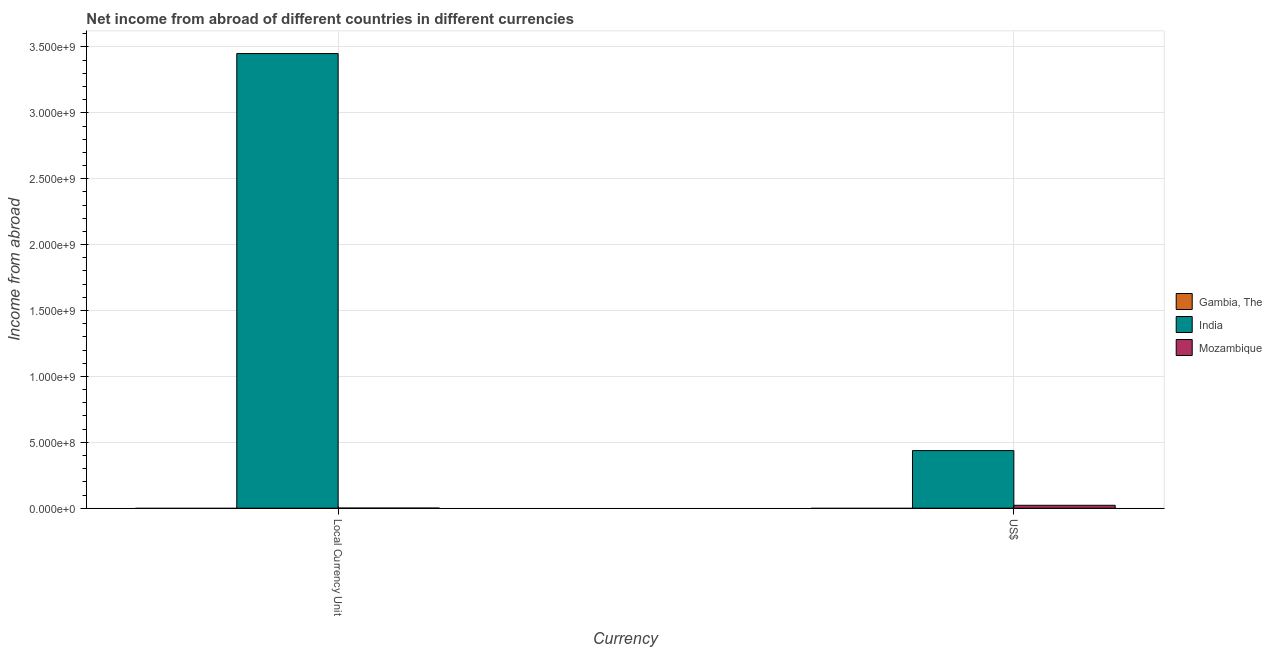What is the label of the 2nd group of bars from the left?
Give a very brief answer. US$. What is the income from abroad in us$ in Mozambique?
Make the answer very short. 2.20e+07. Across all countries, what is the maximum income from abroad in us$?
Give a very brief answer. 4.37e+08. What is the total income from abroad in us$ in the graph?
Offer a terse response. 4.59e+08. What is the difference between the income from abroad in us$ in Mozambique and that in India?
Offer a very short reply. -4.15e+08. What is the difference between the income from abroad in constant 2005 us$ in India and the income from abroad in us$ in Mozambique?
Provide a short and direct response. 3.43e+09. What is the average income from abroad in us$ per country?
Provide a succinct answer. 1.53e+08. What is the difference between the income from abroad in us$ and income from abroad in constant 2005 us$ in India?
Offer a terse response. -3.01e+09. What is the ratio of the income from abroad in constant 2005 us$ in Mozambique to that in India?
Make the answer very short. 0. Are all the bars in the graph horizontal?
Provide a short and direct response. No. Are the values on the major ticks of Y-axis written in scientific E-notation?
Give a very brief answer. Yes. Does the graph contain any zero values?
Ensure brevity in your answer.  Yes. How many legend labels are there?
Keep it short and to the point. 3. What is the title of the graph?
Keep it short and to the point. Net income from abroad of different countries in different currencies. Does "Serbia" appear as one of the legend labels in the graph?
Make the answer very short. No. What is the label or title of the X-axis?
Offer a very short reply. Currency. What is the label or title of the Y-axis?
Provide a short and direct response. Income from abroad. What is the Income from abroad of India in Local Currency Unit?
Offer a very short reply. 3.45e+09. What is the Income from abroad of Mozambique in Local Currency Unit?
Your response must be concise. 7.13e+05. What is the Income from abroad in India in US$?
Offer a very short reply. 4.37e+08. What is the Income from abroad in Mozambique in US$?
Keep it short and to the point. 2.20e+07. Across all Currency, what is the maximum Income from abroad in India?
Your response must be concise. 3.45e+09. Across all Currency, what is the maximum Income from abroad of Mozambique?
Make the answer very short. 2.20e+07. Across all Currency, what is the minimum Income from abroad of India?
Ensure brevity in your answer.  4.37e+08. Across all Currency, what is the minimum Income from abroad of Mozambique?
Provide a succinct answer. 7.13e+05. What is the total Income from abroad of India in the graph?
Keep it short and to the point. 3.89e+09. What is the total Income from abroad in Mozambique in the graph?
Your answer should be compact. 2.27e+07. What is the difference between the Income from abroad of India in Local Currency Unit and that in US$?
Your answer should be very brief. 3.01e+09. What is the difference between the Income from abroad of Mozambique in Local Currency Unit and that in US$?
Make the answer very short. -2.13e+07. What is the difference between the Income from abroad of India in Local Currency Unit and the Income from abroad of Mozambique in US$?
Your response must be concise. 3.43e+09. What is the average Income from abroad of Gambia, The per Currency?
Your answer should be compact. 0. What is the average Income from abroad in India per Currency?
Offer a very short reply. 1.94e+09. What is the average Income from abroad of Mozambique per Currency?
Make the answer very short. 1.14e+07. What is the difference between the Income from abroad in India and Income from abroad in Mozambique in Local Currency Unit?
Provide a short and direct response. 3.45e+09. What is the difference between the Income from abroad in India and Income from abroad in Mozambique in US$?
Provide a short and direct response. 4.15e+08. What is the ratio of the Income from abroad in India in Local Currency Unit to that in US$?
Provide a short and direct response. 7.89. What is the ratio of the Income from abroad of Mozambique in Local Currency Unit to that in US$?
Give a very brief answer. 0.03. What is the difference between the highest and the second highest Income from abroad of India?
Give a very brief answer. 3.01e+09. What is the difference between the highest and the second highest Income from abroad of Mozambique?
Provide a short and direct response. 2.13e+07. What is the difference between the highest and the lowest Income from abroad in India?
Offer a very short reply. 3.01e+09. What is the difference between the highest and the lowest Income from abroad in Mozambique?
Offer a terse response. 2.13e+07. 